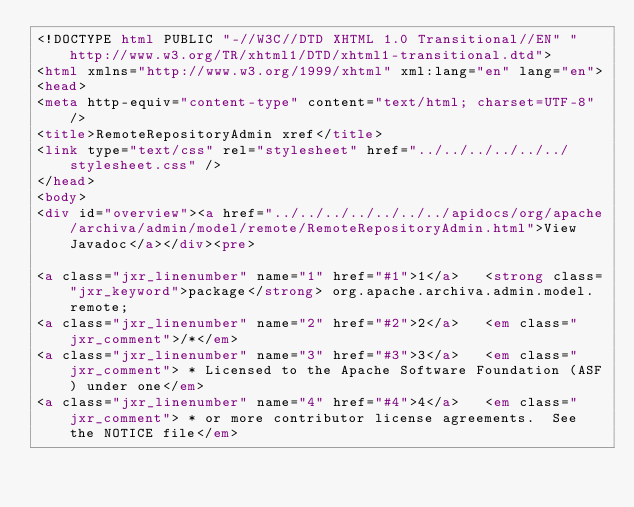Convert code to text. <code><loc_0><loc_0><loc_500><loc_500><_HTML_><!DOCTYPE html PUBLIC "-//W3C//DTD XHTML 1.0 Transitional//EN" "http://www.w3.org/TR/xhtml1/DTD/xhtml1-transitional.dtd">
<html xmlns="http://www.w3.org/1999/xhtml" xml:lang="en" lang="en">
<head>
<meta http-equiv="content-type" content="text/html; charset=UTF-8" />
<title>RemoteRepositoryAdmin xref</title>
<link type="text/css" rel="stylesheet" href="../../../../../../stylesheet.css" />
</head>
<body>
<div id="overview"><a href="../../../../../../../apidocs/org/apache/archiva/admin/model/remote/RemoteRepositoryAdmin.html">View Javadoc</a></div><pre>

<a class="jxr_linenumber" name="1" href="#1">1</a>   <strong class="jxr_keyword">package</strong> org.apache.archiva.admin.model.remote;
<a class="jxr_linenumber" name="2" href="#2">2</a>   <em class="jxr_comment">/*</em>
<a class="jxr_linenumber" name="3" href="#3">3</a>   <em class="jxr_comment"> * Licensed to the Apache Software Foundation (ASF) under one</em>
<a class="jxr_linenumber" name="4" href="#4">4</a>   <em class="jxr_comment"> * or more contributor license agreements.  See the NOTICE file</em></code> 